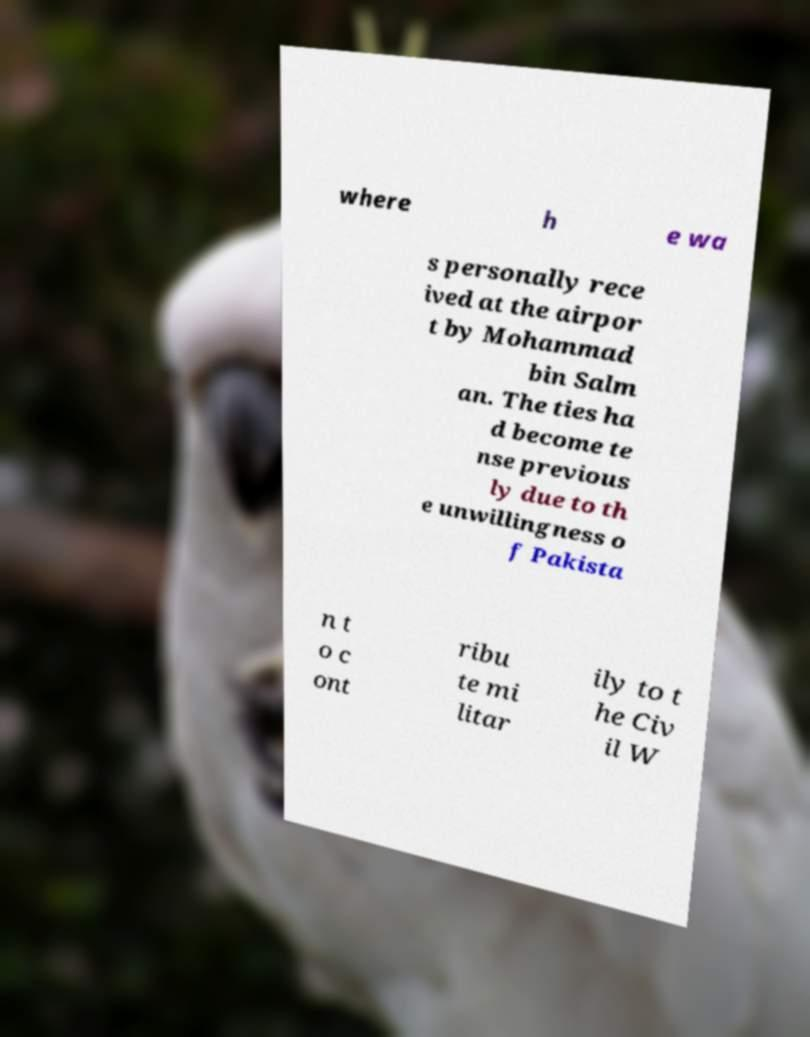Could you assist in decoding the text presented in this image and type it out clearly? where h e wa s personally rece ived at the airpor t by Mohammad bin Salm an. The ties ha d become te nse previous ly due to th e unwillingness o f Pakista n t o c ont ribu te mi litar ily to t he Civ il W 